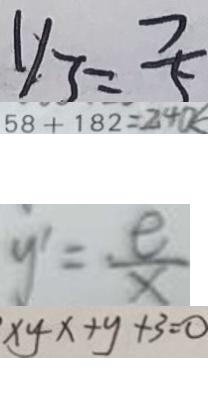<formula> <loc_0><loc_0><loc_500><loc_500>y _ { 3 } = \frac { 7 } { 5 } 
 5 8 + 1 8 2 = 2 4 0 k 
 y ^ { \prime } = \frac { e } { x } 
 x y - x + y + 3 = 0</formula> 